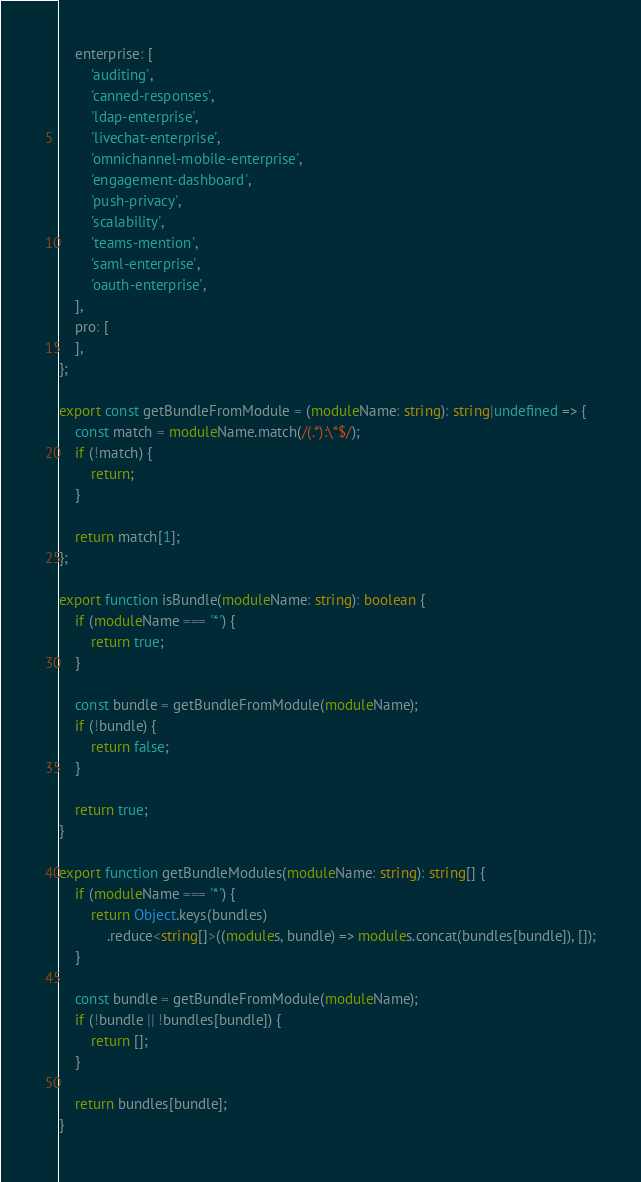<code> <loc_0><loc_0><loc_500><loc_500><_TypeScript_>	enterprise: [
		'auditing',
		'canned-responses',
		'ldap-enterprise',
		'livechat-enterprise',
		'omnichannel-mobile-enterprise',
		'engagement-dashboard',
		'push-privacy',
		'scalability',
		'teams-mention',
		'saml-enterprise',
		'oauth-enterprise',
	],
	pro: [
	],
};

export const getBundleFromModule = (moduleName: string): string|undefined => {
	const match = moduleName.match(/(.*):\*$/);
	if (!match) {
		return;
	}

	return match[1];
};

export function isBundle(moduleName: string): boolean {
	if (moduleName === '*') {
		return true;
	}

	const bundle = getBundleFromModule(moduleName);
	if (!bundle) {
		return false;
	}

	return true;
}

export function getBundleModules(moduleName: string): string[] {
	if (moduleName === '*') {
		return Object.keys(bundles)
			.reduce<string[]>((modules, bundle) => modules.concat(bundles[bundle]), []);
	}

	const bundle = getBundleFromModule(moduleName);
	if (!bundle || !bundles[bundle]) {
		return [];
	}

	return bundles[bundle];
}
</code> 